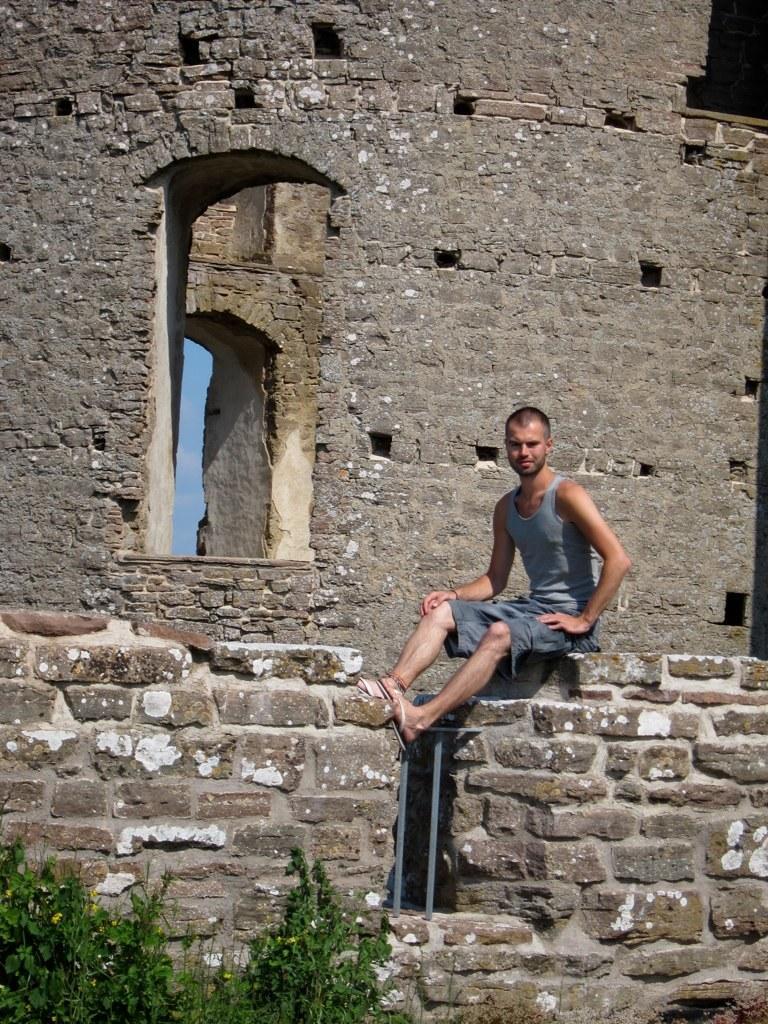Could you give a brief overview of what you see in this image? In this image, there is a person wearing clothes and sitting on the wall. There are some plants in the bottom left of the image. There is a window in the middle of the image. 